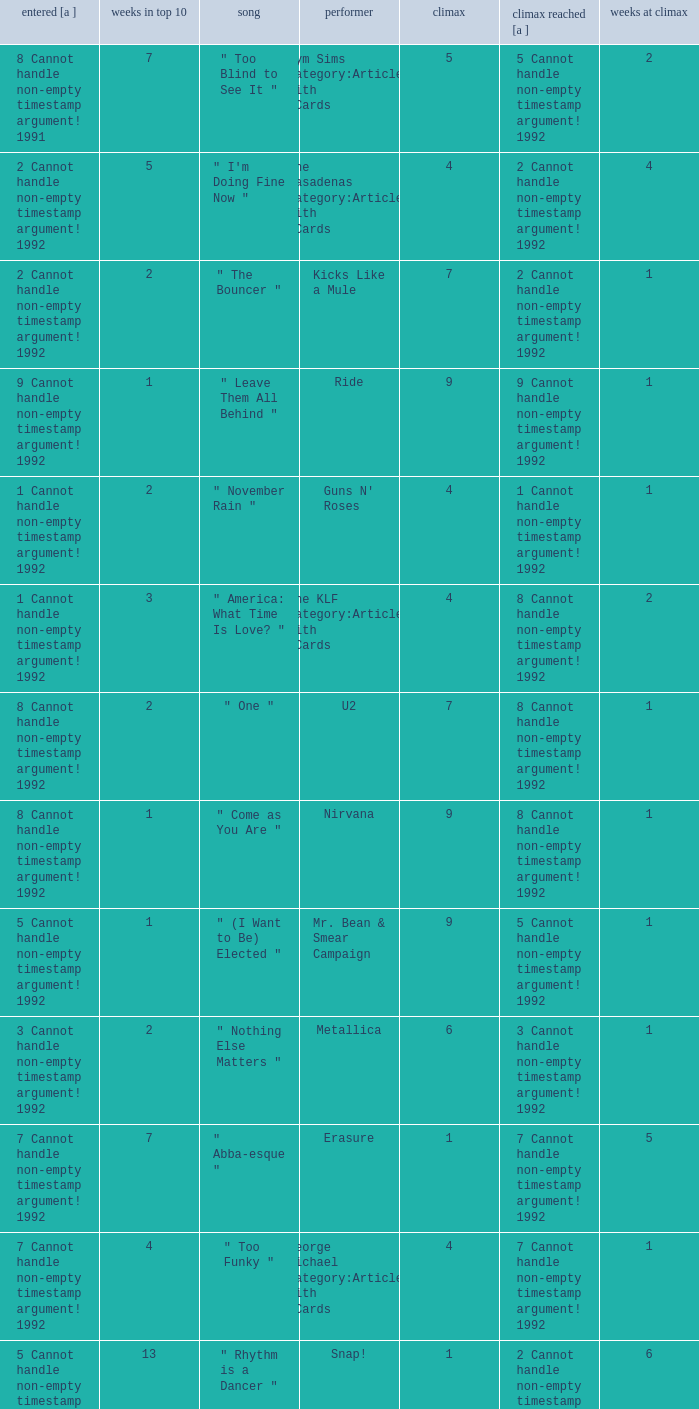If the peak is 9, how many weeks was it in the top 10? 1.0. 